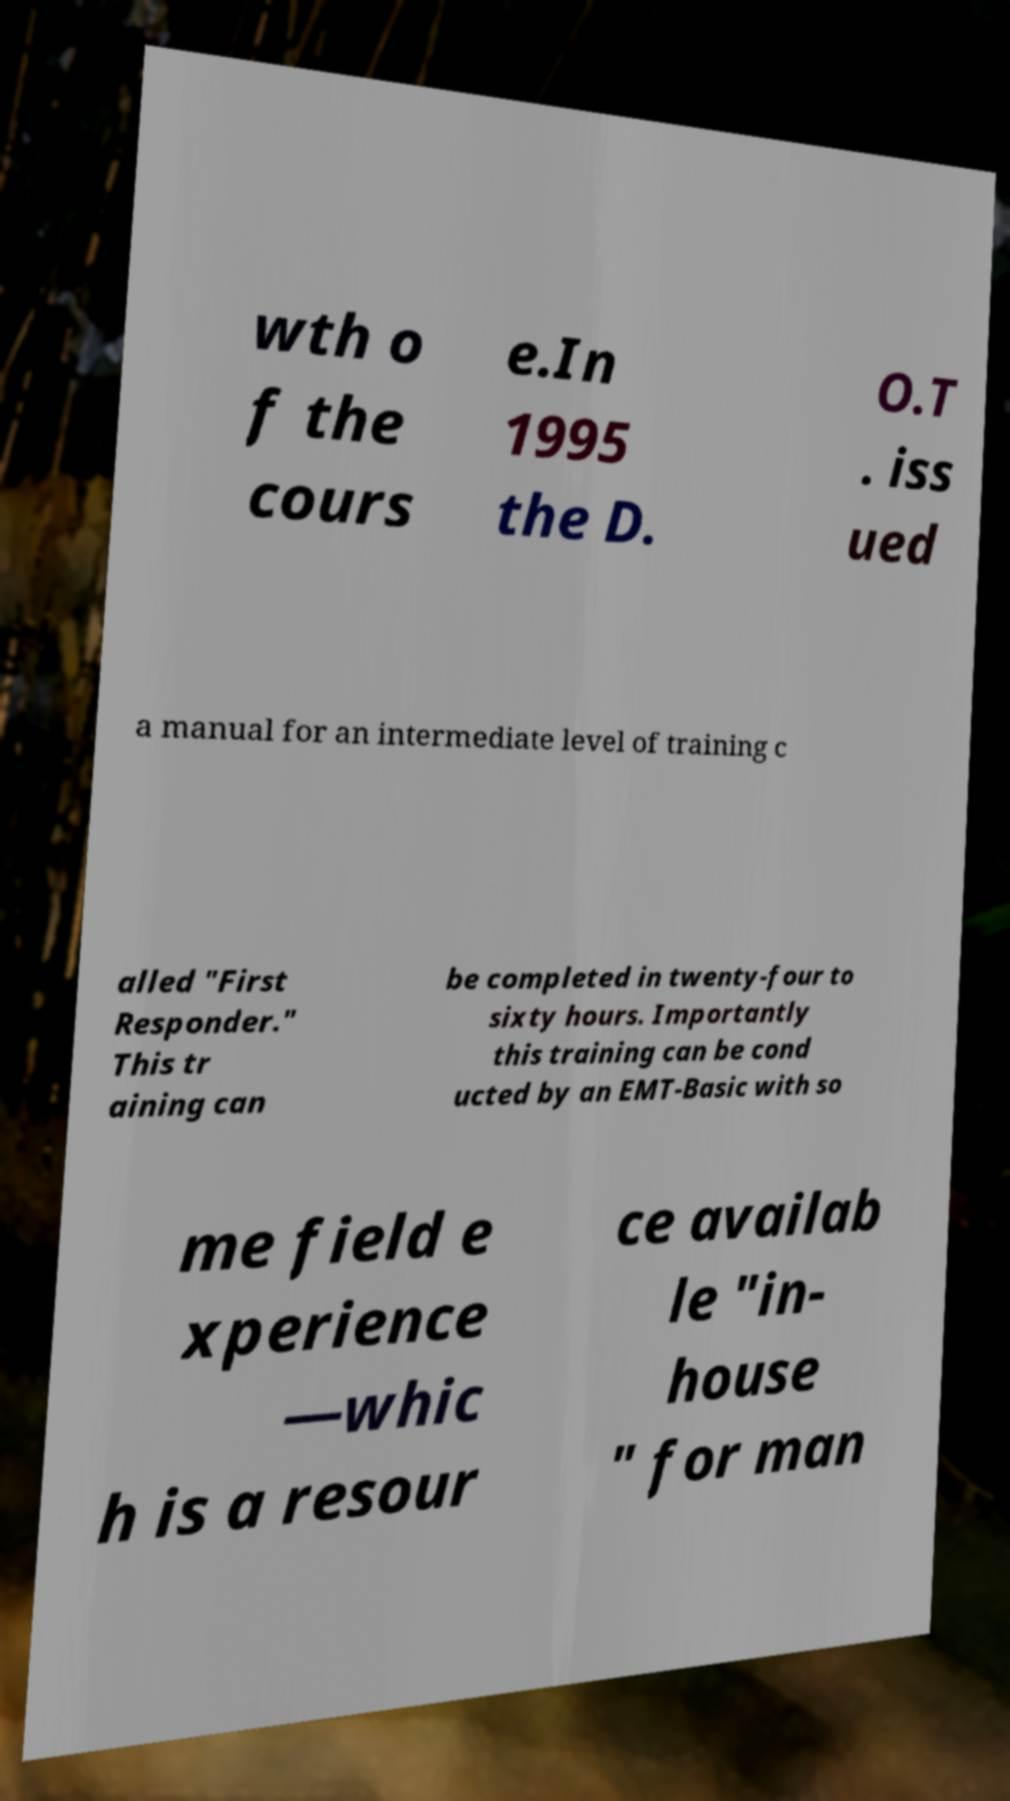What messages or text are displayed in this image? I need them in a readable, typed format. wth o f the cours e.In 1995 the D. O.T . iss ued a manual for an intermediate level of training c alled "First Responder." This tr aining can be completed in twenty-four to sixty hours. Importantly this training can be cond ucted by an EMT-Basic with so me field e xperience —whic h is a resour ce availab le "in- house " for man 